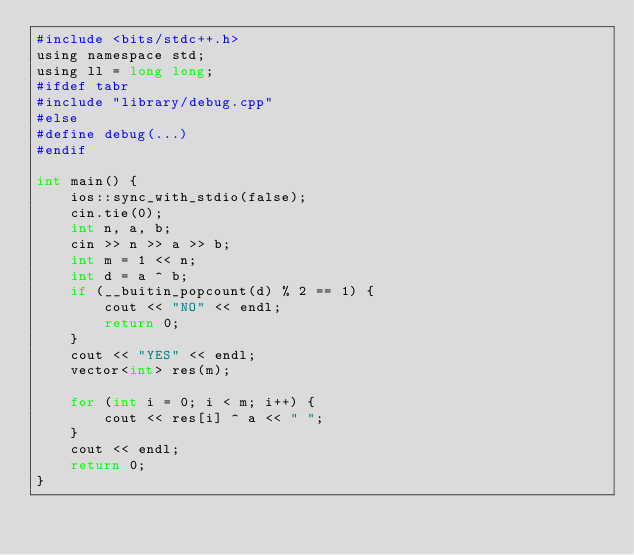Convert code to text. <code><loc_0><loc_0><loc_500><loc_500><_Python_>#include <bits/stdc++.h>
using namespace std;
using ll = long long;
#ifdef tabr
#include "library/debug.cpp"
#else
#define debug(...)
#endif

int main() {
    ios::sync_with_stdio(false);
    cin.tie(0);
    int n, a, b;
    cin >> n >> a >> b;
    int m = 1 << n;
    int d = a ^ b;
    if (__buitin_popcount(d) % 2 == 1) {
        cout << "NO" << endl;
        return 0;
    }
    cout << "YES" << endl;
    vector<int> res(m);

    for (int i = 0; i < m; i++) {
        cout << res[i] ^ a << " ";
    }
    cout << endl;
    return 0;
}</code> 